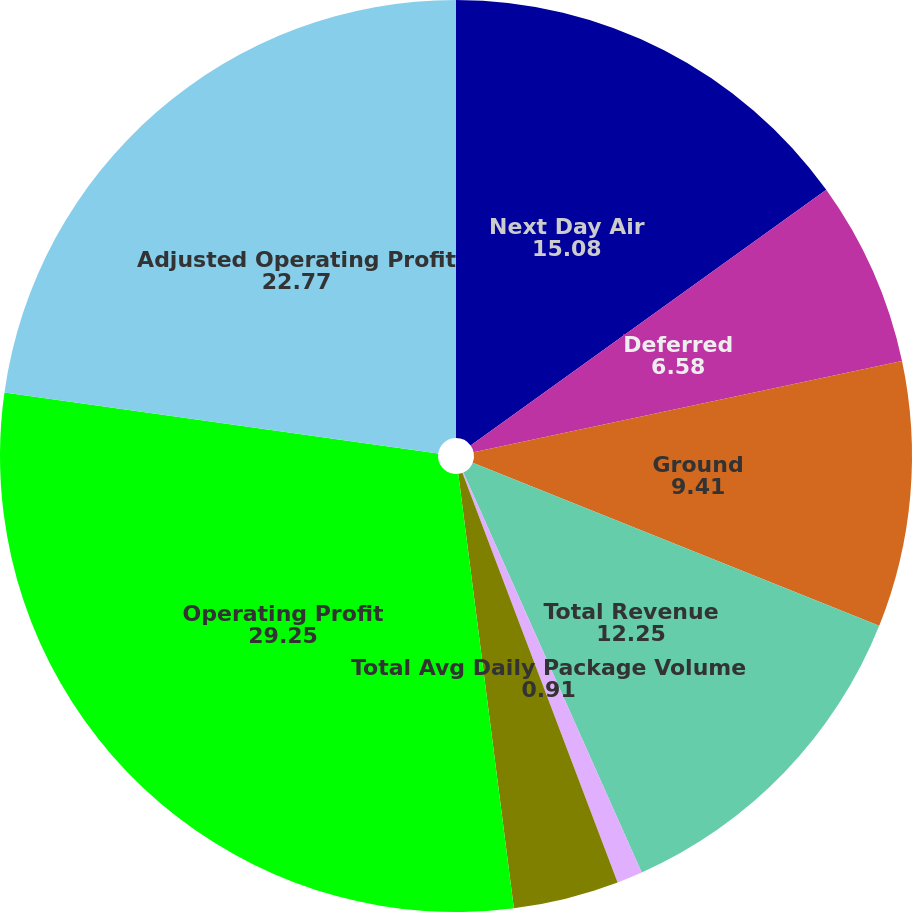Convert chart to OTSL. <chart><loc_0><loc_0><loc_500><loc_500><pie_chart><fcel>Next Day Air<fcel>Deferred<fcel>Ground<fcel>Total Revenue<fcel>Total Avg Daily Package Volume<fcel>Total Avg Revenue Per Piece<fcel>Operating Profit<fcel>Adjusted Operating Profit<nl><fcel>15.08%<fcel>6.58%<fcel>9.41%<fcel>12.25%<fcel>0.91%<fcel>3.74%<fcel>29.25%<fcel>22.77%<nl></chart> 